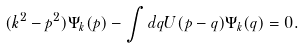<formula> <loc_0><loc_0><loc_500><loc_500>( k ^ { 2 } - p ^ { 2 } ) \Psi _ { k } ( { p } ) - \int d { q } U ( { p } - { q } ) \Psi _ { k } ( { q } ) = 0 .</formula> 